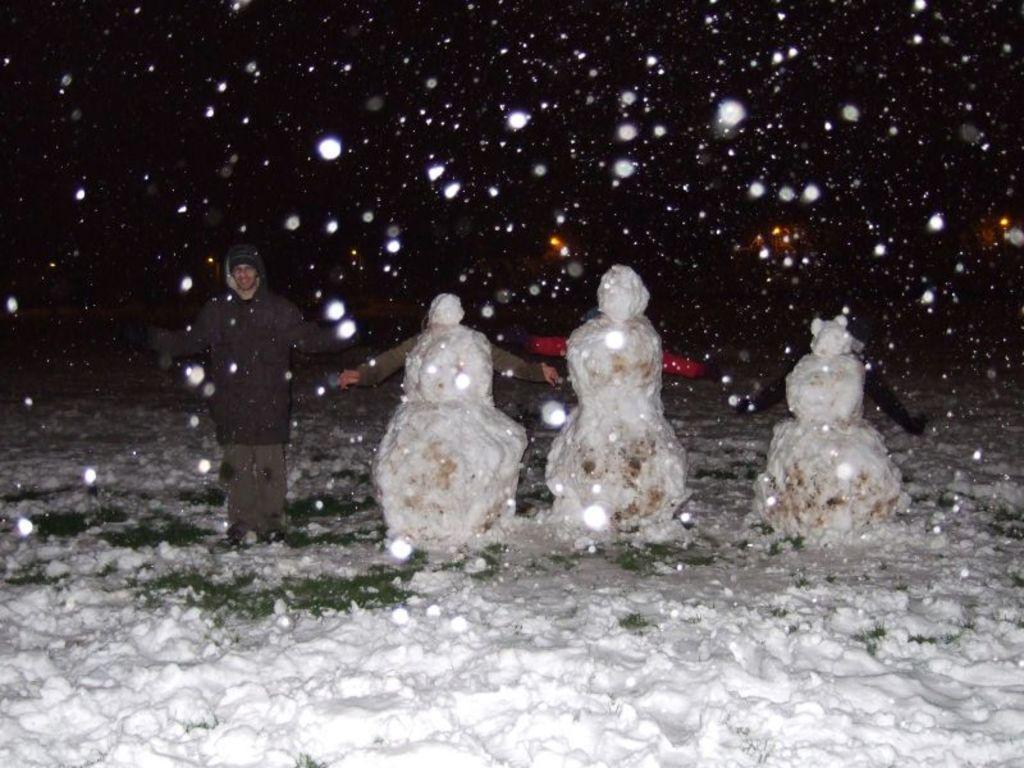Describe this image in one or two sentences. In this picture we can see a person standing in snow. There are few snowman on the path. 